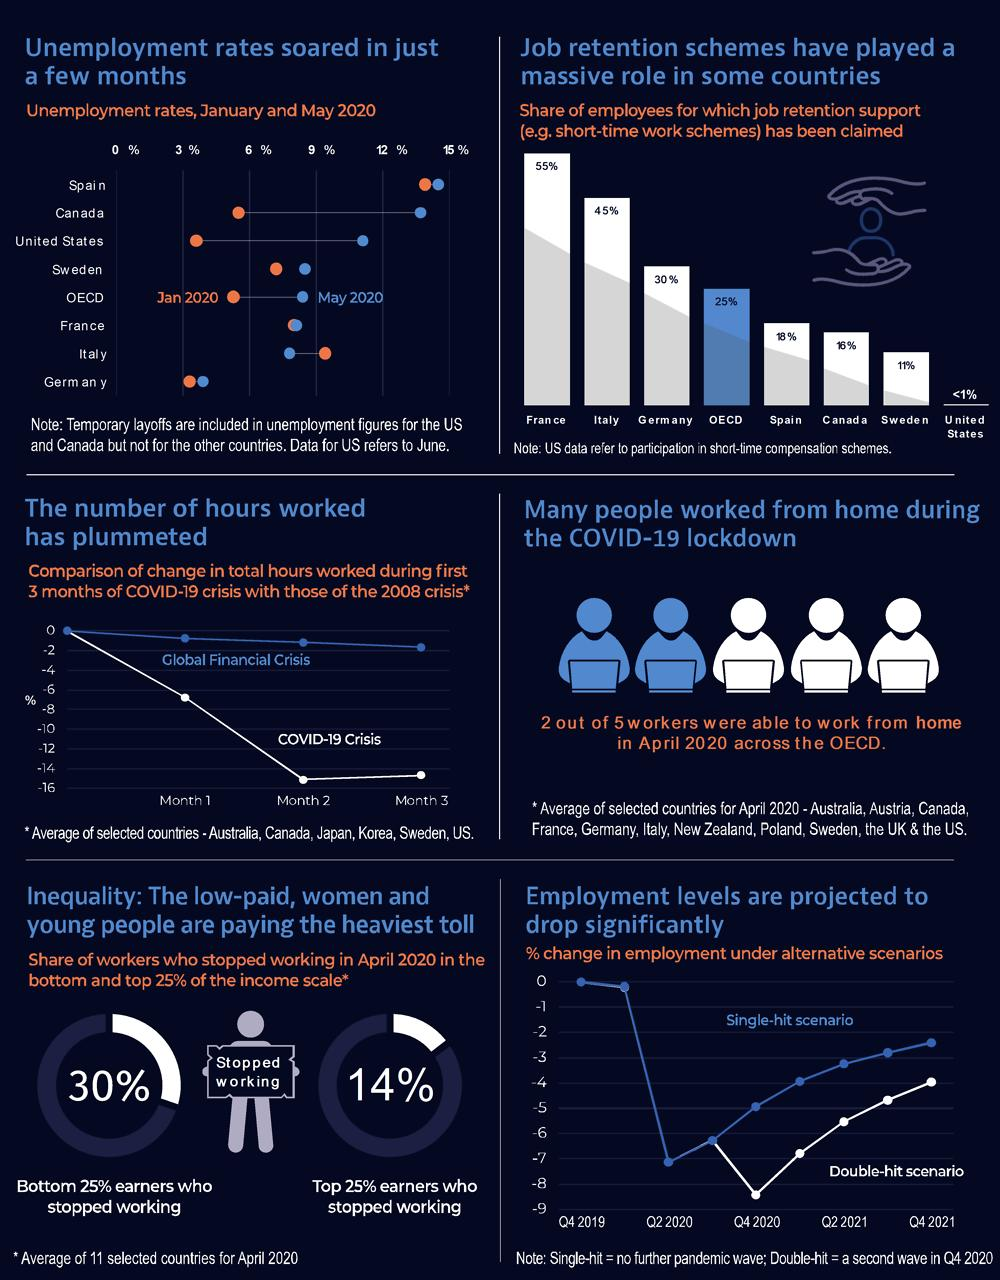List a handful of essential elements in this visual. In April 2020, 30% of workers in the bottom 25% of the income scale had stopped working. In January 2020, the unemployment rate in Italy was reported to be between 9 and 12 percent, making it the country with the highest reported unemployment rate in that month. In May 2020, it was reported that Spain's unemployment rate was greater than 12%. According to data from April 2020, approximately 14% of workers who fall within the top 25% of the income scale have stopped working. A total of 55% of employees in France have claimed their job retention support. 